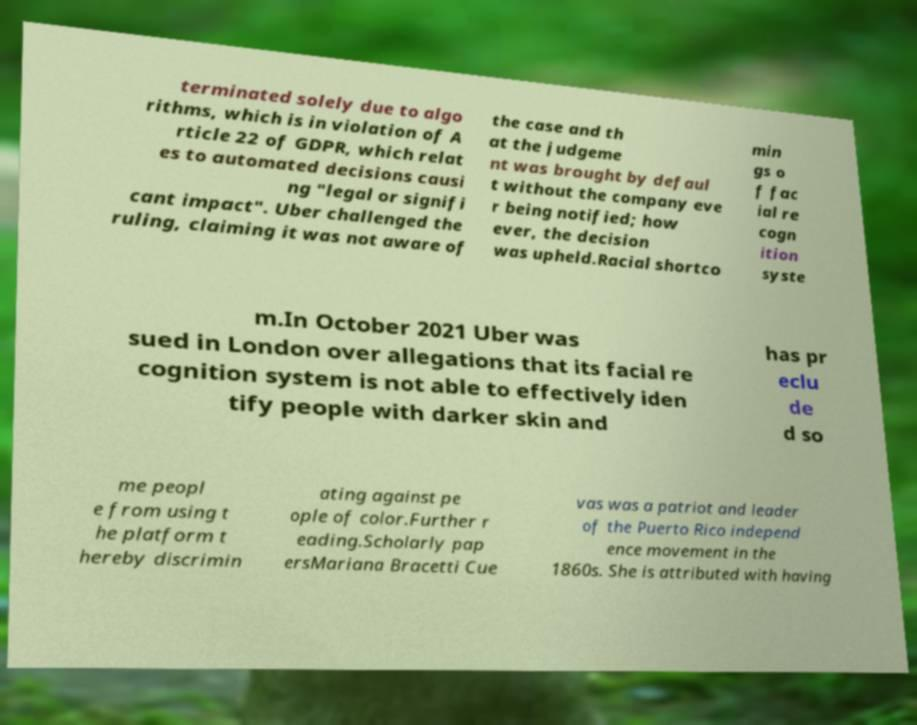Can you read and provide the text displayed in the image?This photo seems to have some interesting text. Can you extract and type it out for me? terminated solely due to algo rithms, which is in violation of A rticle 22 of GDPR, which relat es to automated decisions causi ng "legal or signifi cant impact". Uber challenged the ruling, claiming it was not aware of the case and th at the judgeme nt was brought by defaul t without the company eve r being notified; how ever, the decision was upheld.Racial shortco min gs o f fac ial re cogn ition syste m.In October 2021 Uber was sued in London over allegations that its facial re cognition system is not able to effectively iden tify people with darker skin and has pr eclu de d so me peopl e from using t he platform t hereby discrimin ating against pe ople of color.Further r eading.Scholarly pap ersMariana Bracetti Cue vas was a patriot and leader of the Puerto Rico independ ence movement in the 1860s. She is attributed with having 